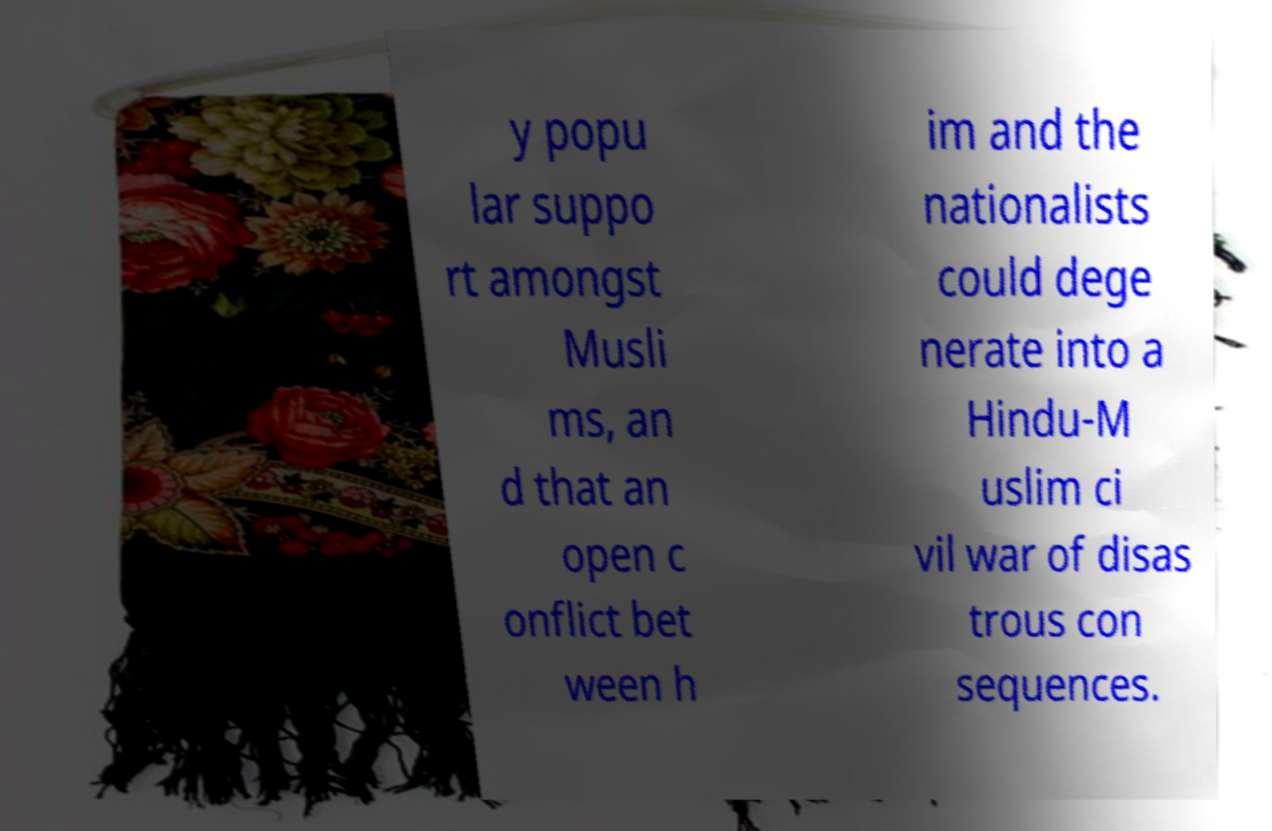Can you read and provide the text displayed in the image?This photo seems to have some interesting text. Can you extract and type it out for me? y popu lar suppo rt amongst Musli ms, an d that an open c onflict bet ween h im and the nationalists could dege nerate into a Hindu-M uslim ci vil war of disas trous con sequences. 